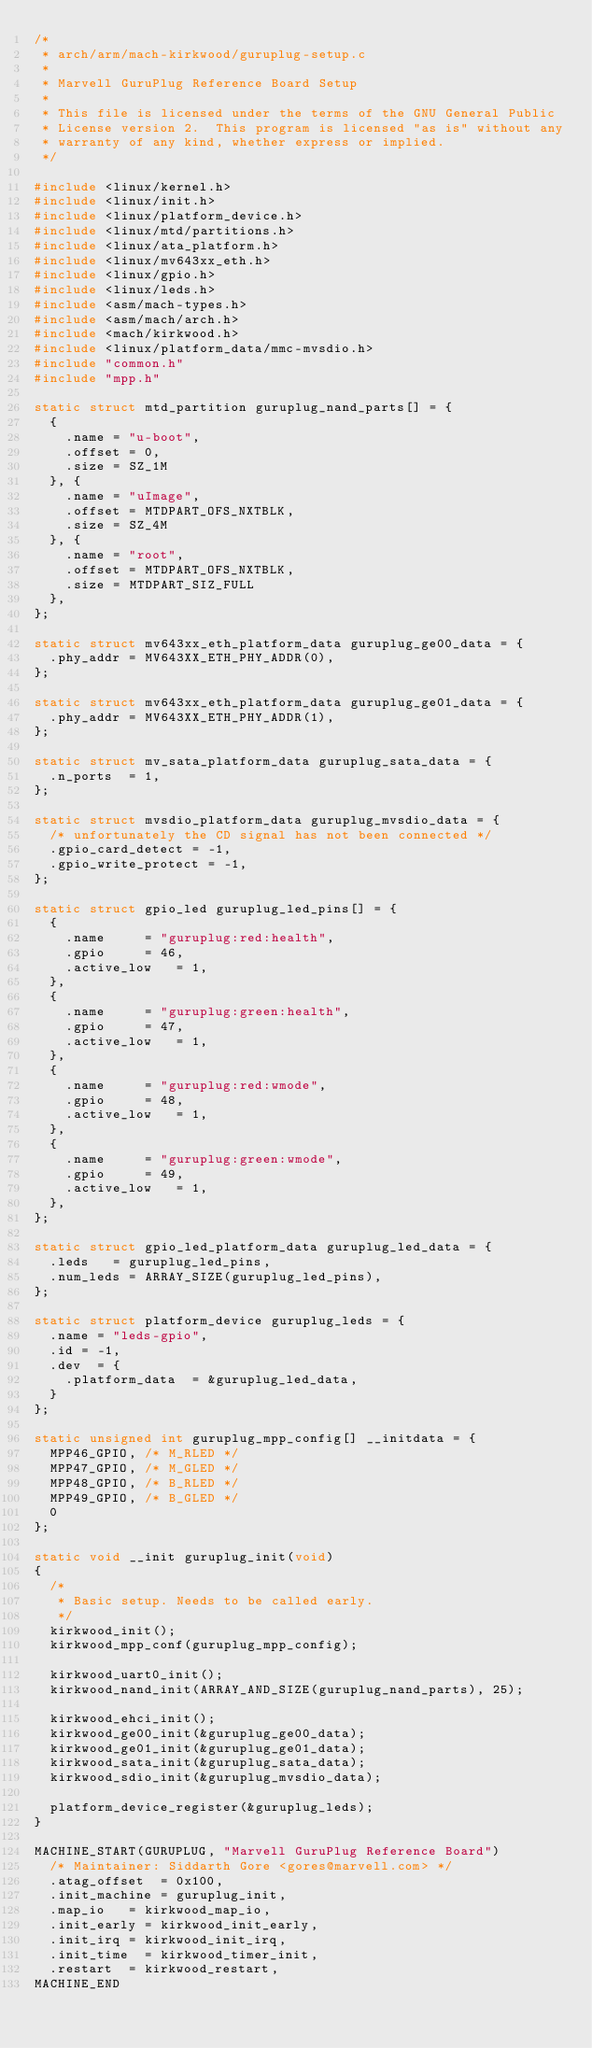Convert code to text. <code><loc_0><loc_0><loc_500><loc_500><_C_>/*
 * arch/arm/mach-kirkwood/guruplug-setup.c
 *
 * Marvell GuruPlug Reference Board Setup
 *
 * This file is licensed under the terms of the GNU General Public
 * License version 2.  This program is licensed "as is" without any
 * warranty of any kind, whether express or implied.
 */

#include <linux/kernel.h>
#include <linux/init.h>
#include <linux/platform_device.h>
#include <linux/mtd/partitions.h>
#include <linux/ata_platform.h>
#include <linux/mv643xx_eth.h>
#include <linux/gpio.h>
#include <linux/leds.h>
#include <asm/mach-types.h>
#include <asm/mach/arch.h>
#include <mach/kirkwood.h>
#include <linux/platform_data/mmc-mvsdio.h>
#include "common.h"
#include "mpp.h"

static struct mtd_partition guruplug_nand_parts[] = {
	{
		.name = "u-boot",
		.offset = 0,
		.size = SZ_1M
	}, {
		.name = "uImage",
		.offset = MTDPART_OFS_NXTBLK,
		.size = SZ_4M
	}, {
		.name = "root",
		.offset = MTDPART_OFS_NXTBLK,
		.size = MTDPART_SIZ_FULL
	},
};

static struct mv643xx_eth_platform_data guruplug_ge00_data = {
	.phy_addr	= MV643XX_ETH_PHY_ADDR(0),
};

static struct mv643xx_eth_platform_data guruplug_ge01_data = {
	.phy_addr	= MV643XX_ETH_PHY_ADDR(1),
};

static struct mv_sata_platform_data guruplug_sata_data = {
	.n_ports	= 1,
};

static struct mvsdio_platform_data guruplug_mvsdio_data = {
	/* unfortunately the CD signal has not been connected */
	.gpio_card_detect = -1,
	.gpio_write_protect = -1,
};

static struct gpio_led guruplug_led_pins[] = {
	{
		.name			= "guruplug:red:health",
		.gpio			= 46,
		.active_low		= 1,
	},
	{
		.name			= "guruplug:green:health",
		.gpio			= 47,
		.active_low		= 1,
	},
	{
		.name			= "guruplug:red:wmode",
		.gpio			= 48,
		.active_low		= 1,
	},
	{
		.name			= "guruplug:green:wmode",
		.gpio			= 49,
		.active_low		= 1,
	},
};

static struct gpio_led_platform_data guruplug_led_data = {
	.leds		= guruplug_led_pins,
	.num_leds	= ARRAY_SIZE(guruplug_led_pins),
};

static struct platform_device guruplug_leds = {
	.name	= "leds-gpio",
	.id	= -1,
	.dev	= {
		.platform_data	= &guruplug_led_data,
	}
};

static unsigned int guruplug_mpp_config[] __initdata = {
	MPP46_GPIO,	/* M_RLED */
	MPP47_GPIO,	/* M_GLED */
	MPP48_GPIO,	/* B_RLED */
	MPP49_GPIO,	/* B_GLED */
	0
};

static void __init guruplug_init(void)
{
	/*
	 * Basic setup. Needs to be called early.
	 */
	kirkwood_init();
	kirkwood_mpp_conf(guruplug_mpp_config);

	kirkwood_uart0_init();
	kirkwood_nand_init(ARRAY_AND_SIZE(guruplug_nand_parts), 25);

	kirkwood_ehci_init();
	kirkwood_ge00_init(&guruplug_ge00_data);
	kirkwood_ge01_init(&guruplug_ge01_data);
	kirkwood_sata_init(&guruplug_sata_data);
	kirkwood_sdio_init(&guruplug_mvsdio_data);

	platform_device_register(&guruplug_leds);
}

MACHINE_START(GURUPLUG, "Marvell GuruPlug Reference Board")
	/* Maintainer: Siddarth Gore <gores@marvell.com> */
	.atag_offset	= 0x100,
	.init_machine	= guruplug_init,
	.map_io		= kirkwood_map_io,
	.init_early	= kirkwood_init_early,
	.init_irq	= kirkwood_init_irq,
	.init_time	= kirkwood_timer_init,
	.restart	= kirkwood_restart,
MACHINE_END
</code> 